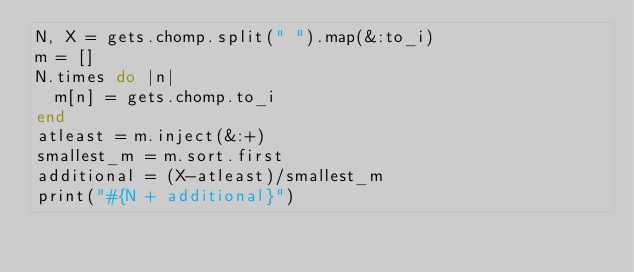<code> <loc_0><loc_0><loc_500><loc_500><_Ruby_>N, X = gets.chomp.split(" ").map(&:to_i)
m = []
N.times do |n|
  m[n] = gets.chomp.to_i
end
atleast = m.inject(&:+)
smallest_m = m.sort.first
additional = (X-atleast)/smallest_m
print("#{N + additional}")</code> 